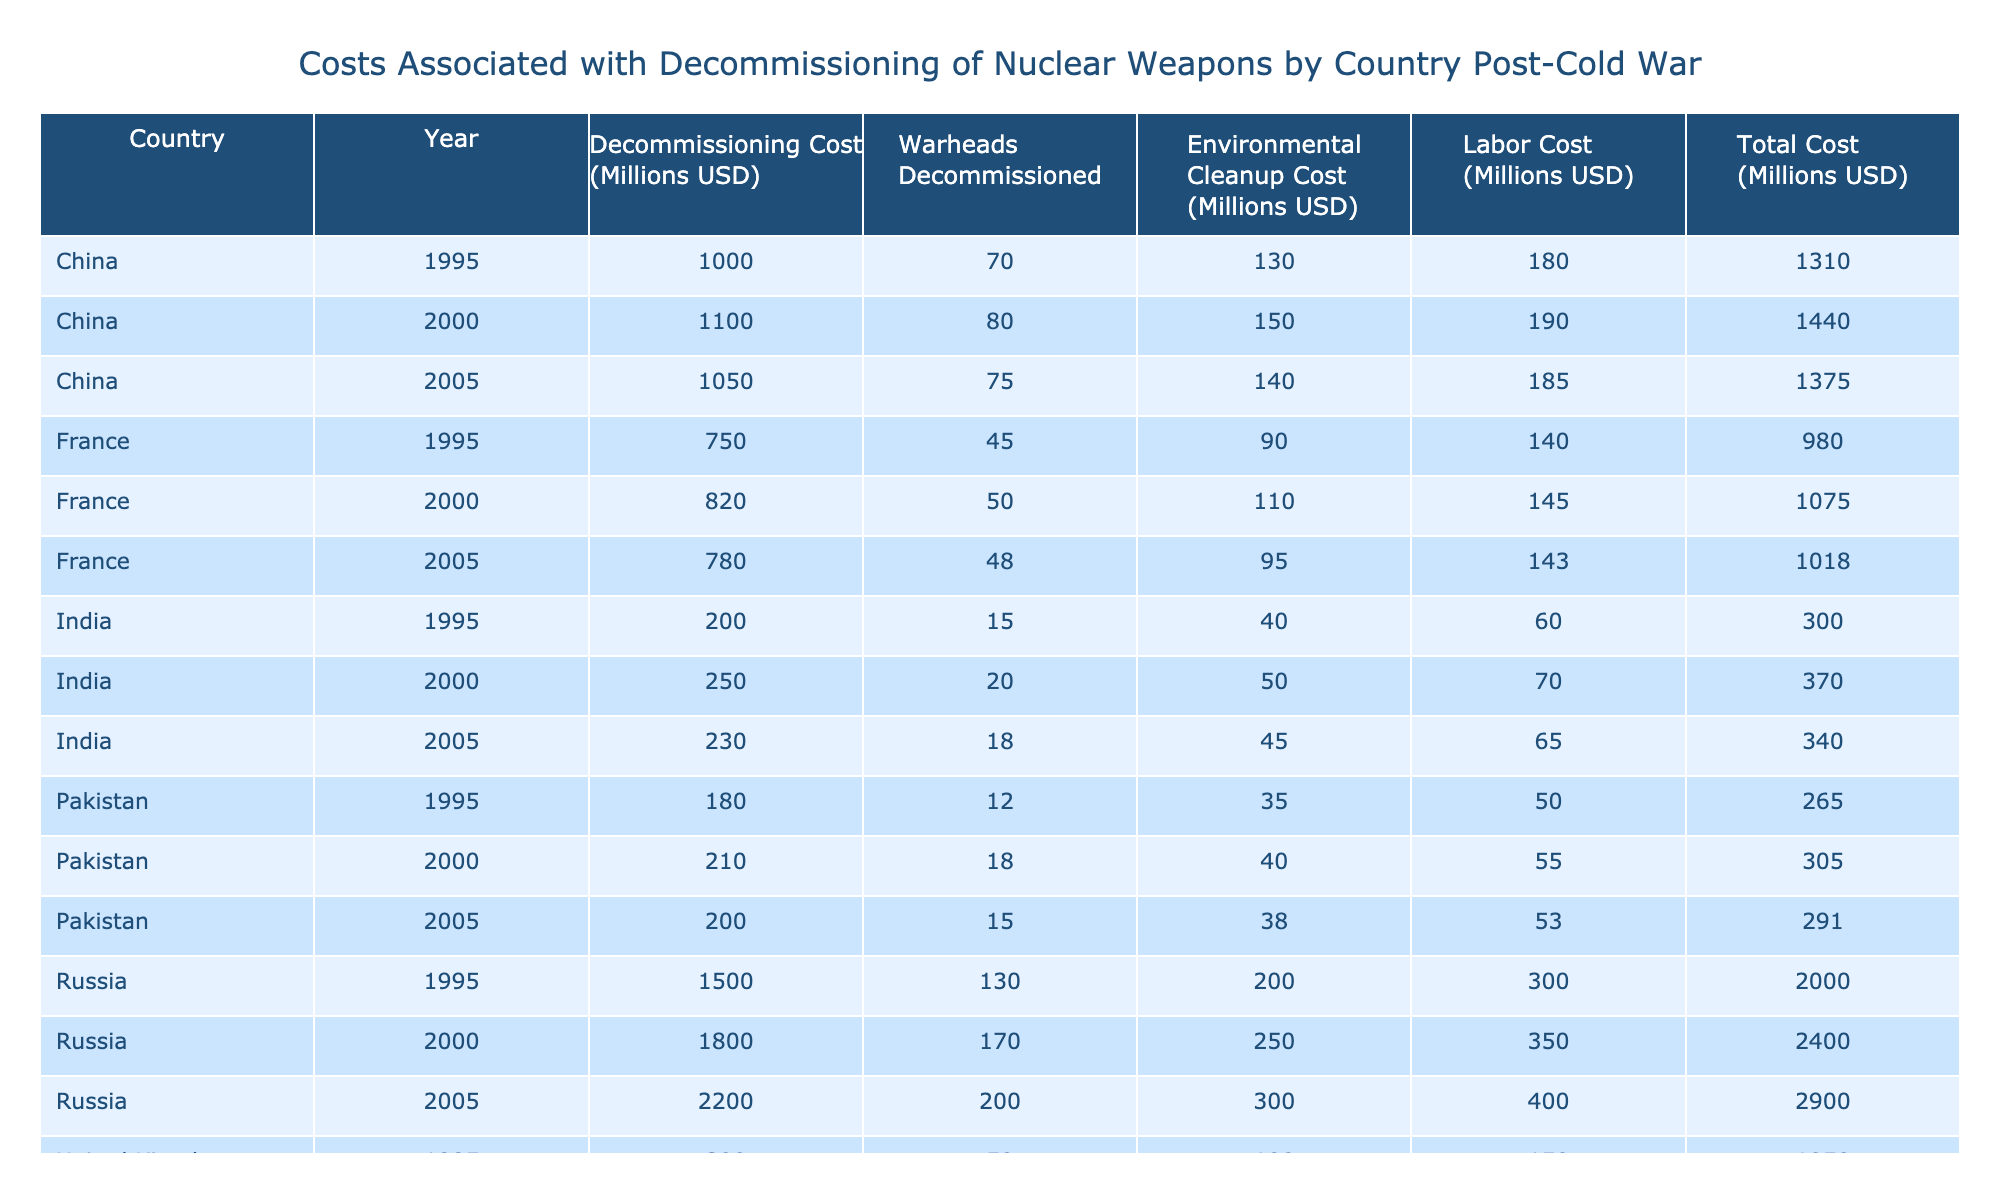What was the total decommissioning cost for the United States in 2000? In the table, I look for the row where the country is "United States" and the year is "2000." The decommissioning cost for that entry is 3000 million USD.
Answer: 3000 million USD How many warheads were decommissioned by Russia in 2005? I find the row for "Russia" in the year "2005," where it indicates that 200 warheads were decommissioned.
Answer: 200 What was the average environmental cleanup cost for the countries listed in 2000? To calculate the average for 2000, I take the environmental cleanup costs from all entries for that year: (450 + 250 + 120 + 110 + 150 + 50 + 40) = 1200 million USD. There are 7 entries, so the average is 1200/7 = approximately 171.43 million USD.
Answer: 171.43 million USD Did China incur a higher total cost than France in 2005? I sum the total costs for China and France in 2005. For China, the total cost is 1050 + 140 + 185 = 1375 million USD, and for France, it is 780 + 95 + 143 = 1018 million USD. Since 1375 is greater than 1018, the answer is yes.
Answer: Yes What was the highest decommissioning cost recorded in the table, and which country and year does it correspond to? I review all decommissioning costs in the table and find that the highest cost is 3000 million USD, which corresponds to the United States in the year 2000.
Answer: 3000 million USD, United States, 2000 What is the total labor cost for all countries combined in 1995? I extract the labor costs for each country in 1995: 500 + 300 + 150 + 140 + 180 + 60 + 50 = 1380 million USD. This sum represents the total labor cost for the year across all countries.
Answer: 1380 million USD How much did the United Kingdom spend on decommissioning costs from 1995 to 2005? I add the decommissioning costs for the UK from each relevant year: 800 + 900 + 850 = 2550 million USD. This total reflects the expenditures over the specified time period.
Answer: 2550 million USD Was there a decrease in the total decommissioning cost or an increase from 2000 to 2005 in Russia? I compare the total costs from 2000 (1800 + 250 + 350 = 2400 million USD) and 2005 (2200 + 300 + 400 = 2900 million USD). The costs increased from 2400 million USD to 2900 million USD, indicating an increase.
Answer: Increase 